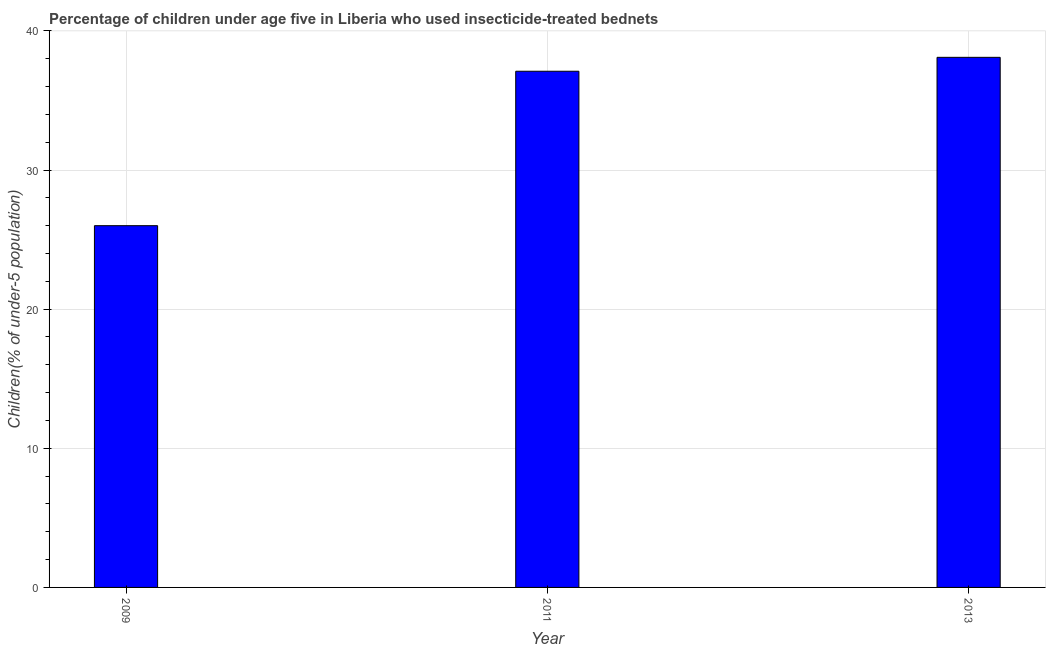What is the title of the graph?
Give a very brief answer. Percentage of children under age five in Liberia who used insecticide-treated bednets. What is the label or title of the Y-axis?
Provide a succinct answer. Children(% of under-5 population). What is the percentage of children who use of insecticide-treated bed nets in 2013?
Make the answer very short. 38.1. Across all years, what is the maximum percentage of children who use of insecticide-treated bed nets?
Your answer should be compact. 38.1. Across all years, what is the minimum percentage of children who use of insecticide-treated bed nets?
Keep it short and to the point. 26. In which year was the percentage of children who use of insecticide-treated bed nets minimum?
Ensure brevity in your answer.  2009. What is the sum of the percentage of children who use of insecticide-treated bed nets?
Make the answer very short. 101.2. What is the difference between the percentage of children who use of insecticide-treated bed nets in 2011 and 2013?
Offer a terse response. -1. What is the average percentage of children who use of insecticide-treated bed nets per year?
Your answer should be very brief. 33.73. What is the median percentage of children who use of insecticide-treated bed nets?
Offer a terse response. 37.1. In how many years, is the percentage of children who use of insecticide-treated bed nets greater than 28 %?
Your answer should be compact. 2. What is the ratio of the percentage of children who use of insecticide-treated bed nets in 2009 to that in 2013?
Your response must be concise. 0.68. Is the percentage of children who use of insecticide-treated bed nets in 2011 less than that in 2013?
Ensure brevity in your answer.  Yes. Is the difference between the percentage of children who use of insecticide-treated bed nets in 2009 and 2011 greater than the difference between any two years?
Your response must be concise. No. What is the difference between the highest and the second highest percentage of children who use of insecticide-treated bed nets?
Provide a succinct answer. 1. Is the sum of the percentage of children who use of insecticide-treated bed nets in 2009 and 2011 greater than the maximum percentage of children who use of insecticide-treated bed nets across all years?
Ensure brevity in your answer.  Yes. What is the difference between the highest and the lowest percentage of children who use of insecticide-treated bed nets?
Give a very brief answer. 12.1. How many bars are there?
Offer a terse response. 3. How many years are there in the graph?
Offer a terse response. 3. What is the difference between two consecutive major ticks on the Y-axis?
Make the answer very short. 10. Are the values on the major ticks of Y-axis written in scientific E-notation?
Your answer should be compact. No. What is the Children(% of under-5 population) in 2009?
Your answer should be compact. 26. What is the Children(% of under-5 population) in 2011?
Ensure brevity in your answer.  37.1. What is the Children(% of under-5 population) of 2013?
Give a very brief answer. 38.1. What is the difference between the Children(% of under-5 population) in 2009 and 2011?
Provide a succinct answer. -11.1. What is the difference between the Children(% of under-5 population) in 2009 and 2013?
Keep it short and to the point. -12.1. What is the ratio of the Children(% of under-5 population) in 2009 to that in 2011?
Provide a succinct answer. 0.7. What is the ratio of the Children(% of under-5 population) in 2009 to that in 2013?
Provide a short and direct response. 0.68. What is the ratio of the Children(% of under-5 population) in 2011 to that in 2013?
Keep it short and to the point. 0.97. 